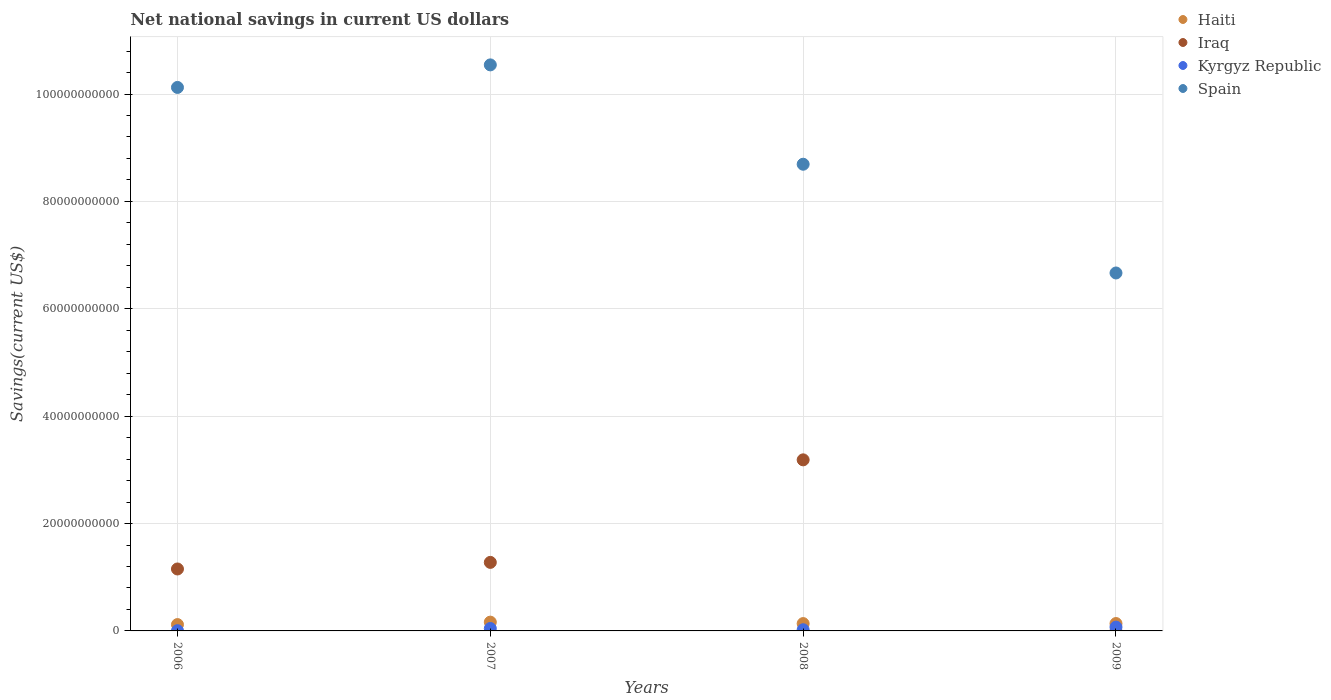How many different coloured dotlines are there?
Ensure brevity in your answer.  4. What is the net national savings in Kyrgyz Republic in 2009?
Ensure brevity in your answer.  7.09e+08. Across all years, what is the maximum net national savings in Haiti?
Provide a succinct answer. 1.64e+09. Across all years, what is the minimum net national savings in Iraq?
Offer a terse response. 0. What is the total net national savings in Spain in the graph?
Provide a succinct answer. 3.60e+11. What is the difference between the net national savings in Haiti in 2006 and that in 2008?
Offer a very short reply. -1.86e+08. What is the difference between the net national savings in Iraq in 2007 and the net national savings in Spain in 2008?
Keep it short and to the point. -7.42e+1. What is the average net national savings in Kyrgyz Republic per year?
Provide a succinct answer. 3.55e+08. In the year 2007, what is the difference between the net national savings in Spain and net national savings in Kyrgyz Republic?
Ensure brevity in your answer.  1.05e+11. What is the ratio of the net national savings in Spain in 2008 to that in 2009?
Your answer should be compact. 1.3. Is the difference between the net national savings in Spain in 2006 and 2007 greater than the difference between the net national savings in Kyrgyz Republic in 2006 and 2007?
Make the answer very short. No. What is the difference between the highest and the second highest net national savings in Iraq?
Give a very brief answer. 1.91e+1. What is the difference between the highest and the lowest net national savings in Kyrgyz Republic?
Offer a very short reply. 6.67e+08. In how many years, is the net national savings in Spain greater than the average net national savings in Spain taken over all years?
Ensure brevity in your answer.  2. Is it the case that in every year, the sum of the net national savings in Haiti and net national savings in Kyrgyz Republic  is greater than the sum of net national savings in Iraq and net national savings in Spain?
Make the answer very short. Yes. Is it the case that in every year, the sum of the net national savings in Iraq and net national savings in Haiti  is greater than the net national savings in Kyrgyz Republic?
Give a very brief answer. Yes. Is the net national savings in Spain strictly less than the net national savings in Iraq over the years?
Provide a short and direct response. No. How many dotlines are there?
Your answer should be compact. 4. Are the values on the major ticks of Y-axis written in scientific E-notation?
Offer a very short reply. No. Does the graph contain any zero values?
Offer a very short reply. Yes. How many legend labels are there?
Ensure brevity in your answer.  4. How are the legend labels stacked?
Ensure brevity in your answer.  Vertical. What is the title of the graph?
Offer a very short reply. Net national savings in current US dollars. Does "Greece" appear as one of the legend labels in the graph?
Keep it short and to the point. No. What is the label or title of the X-axis?
Offer a terse response. Years. What is the label or title of the Y-axis?
Your answer should be very brief. Savings(current US$). What is the Savings(current US$) in Haiti in 2006?
Provide a short and direct response. 1.18e+09. What is the Savings(current US$) of Iraq in 2006?
Ensure brevity in your answer.  1.15e+1. What is the Savings(current US$) in Kyrgyz Republic in 2006?
Give a very brief answer. 4.16e+07. What is the Savings(current US$) in Spain in 2006?
Offer a terse response. 1.01e+11. What is the Savings(current US$) in Haiti in 2007?
Give a very brief answer. 1.64e+09. What is the Savings(current US$) of Iraq in 2007?
Keep it short and to the point. 1.28e+1. What is the Savings(current US$) in Kyrgyz Republic in 2007?
Give a very brief answer. 4.53e+08. What is the Savings(current US$) in Spain in 2007?
Your answer should be compact. 1.05e+11. What is the Savings(current US$) of Haiti in 2008?
Provide a succinct answer. 1.37e+09. What is the Savings(current US$) in Iraq in 2008?
Your answer should be very brief. 3.19e+1. What is the Savings(current US$) of Kyrgyz Republic in 2008?
Offer a very short reply. 2.18e+08. What is the Savings(current US$) of Spain in 2008?
Provide a succinct answer. 8.69e+1. What is the Savings(current US$) of Haiti in 2009?
Ensure brevity in your answer.  1.38e+09. What is the Savings(current US$) of Kyrgyz Republic in 2009?
Make the answer very short. 7.09e+08. What is the Savings(current US$) of Spain in 2009?
Give a very brief answer. 6.67e+1. Across all years, what is the maximum Savings(current US$) of Haiti?
Make the answer very short. 1.64e+09. Across all years, what is the maximum Savings(current US$) of Iraq?
Your answer should be compact. 3.19e+1. Across all years, what is the maximum Savings(current US$) in Kyrgyz Republic?
Make the answer very short. 7.09e+08. Across all years, what is the maximum Savings(current US$) of Spain?
Keep it short and to the point. 1.05e+11. Across all years, what is the minimum Savings(current US$) in Haiti?
Provide a short and direct response. 1.18e+09. Across all years, what is the minimum Savings(current US$) of Iraq?
Provide a short and direct response. 0. Across all years, what is the minimum Savings(current US$) in Kyrgyz Republic?
Provide a short and direct response. 4.16e+07. Across all years, what is the minimum Savings(current US$) in Spain?
Provide a succinct answer. 6.67e+1. What is the total Savings(current US$) in Haiti in the graph?
Give a very brief answer. 5.56e+09. What is the total Savings(current US$) in Iraq in the graph?
Offer a very short reply. 5.62e+1. What is the total Savings(current US$) in Kyrgyz Republic in the graph?
Ensure brevity in your answer.  1.42e+09. What is the total Savings(current US$) in Spain in the graph?
Provide a succinct answer. 3.60e+11. What is the difference between the Savings(current US$) of Haiti in 2006 and that in 2007?
Provide a short and direct response. -4.55e+08. What is the difference between the Savings(current US$) in Iraq in 2006 and that in 2007?
Provide a succinct answer. -1.23e+09. What is the difference between the Savings(current US$) in Kyrgyz Republic in 2006 and that in 2007?
Give a very brief answer. -4.11e+08. What is the difference between the Savings(current US$) of Spain in 2006 and that in 2007?
Provide a short and direct response. -4.20e+09. What is the difference between the Savings(current US$) of Haiti in 2006 and that in 2008?
Your answer should be compact. -1.86e+08. What is the difference between the Savings(current US$) of Iraq in 2006 and that in 2008?
Give a very brief answer. -2.03e+1. What is the difference between the Savings(current US$) of Kyrgyz Republic in 2006 and that in 2008?
Offer a very short reply. -1.77e+08. What is the difference between the Savings(current US$) in Spain in 2006 and that in 2008?
Your answer should be compact. 1.43e+1. What is the difference between the Savings(current US$) of Haiti in 2006 and that in 2009?
Offer a terse response. -1.95e+08. What is the difference between the Savings(current US$) in Kyrgyz Republic in 2006 and that in 2009?
Provide a short and direct response. -6.67e+08. What is the difference between the Savings(current US$) in Spain in 2006 and that in 2009?
Your response must be concise. 3.46e+1. What is the difference between the Savings(current US$) of Haiti in 2007 and that in 2008?
Offer a terse response. 2.69e+08. What is the difference between the Savings(current US$) of Iraq in 2007 and that in 2008?
Give a very brief answer. -1.91e+1. What is the difference between the Savings(current US$) of Kyrgyz Republic in 2007 and that in 2008?
Your response must be concise. 2.34e+08. What is the difference between the Savings(current US$) in Spain in 2007 and that in 2008?
Your answer should be compact. 1.85e+1. What is the difference between the Savings(current US$) of Haiti in 2007 and that in 2009?
Provide a succinct answer. 2.60e+08. What is the difference between the Savings(current US$) of Kyrgyz Republic in 2007 and that in 2009?
Your response must be concise. -2.56e+08. What is the difference between the Savings(current US$) of Spain in 2007 and that in 2009?
Keep it short and to the point. 3.88e+1. What is the difference between the Savings(current US$) of Haiti in 2008 and that in 2009?
Your answer should be compact. -9.73e+06. What is the difference between the Savings(current US$) in Kyrgyz Republic in 2008 and that in 2009?
Your answer should be compact. -4.90e+08. What is the difference between the Savings(current US$) in Spain in 2008 and that in 2009?
Provide a succinct answer. 2.03e+1. What is the difference between the Savings(current US$) in Haiti in 2006 and the Savings(current US$) in Iraq in 2007?
Ensure brevity in your answer.  -1.16e+1. What is the difference between the Savings(current US$) in Haiti in 2006 and the Savings(current US$) in Kyrgyz Republic in 2007?
Provide a succinct answer. 7.28e+08. What is the difference between the Savings(current US$) in Haiti in 2006 and the Savings(current US$) in Spain in 2007?
Give a very brief answer. -1.04e+11. What is the difference between the Savings(current US$) of Iraq in 2006 and the Savings(current US$) of Kyrgyz Republic in 2007?
Make the answer very short. 1.11e+1. What is the difference between the Savings(current US$) in Iraq in 2006 and the Savings(current US$) in Spain in 2007?
Give a very brief answer. -9.39e+1. What is the difference between the Savings(current US$) of Kyrgyz Republic in 2006 and the Savings(current US$) of Spain in 2007?
Give a very brief answer. -1.05e+11. What is the difference between the Savings(current US$) of Haiti in 2006 and the Savings(current US$) of Iraq in 2008?
Provide a short and direct response. -3.07e+1. What is the difference between the Savings(current US$) of Haiti in 2006 and the Savings(current US$) of Kyrgyz Republic in 2008?
Provide a succinct answer. 9.62e+08. What is the difference between the Savings(current US$) in Haiti in 2006 and the Savings(current US$) in Spain in 2008?
Keep it short and to the point. -8.57e+1. What is the difference between the Savings(current US$) in Iraq in 2006 and the Savings(current US$) in Kyrgyz Republic in 2008?
Your response must be concise. 1.13e+1. What is the difference between the Savings(current US$) in Iraq in 2006 and the Savings(current US$) in Spain in 2008?
Provide a short and direct response. -7.54e+1. What is the difference between the Savings(current US$) of Kyrgyz Republic in 2006 and the Savings(current US$) of Spain in 2008?
Make the answer very short. -8.69e+1. What is the difference between the Savings(current US$) of Haiti in 2006 and the Savings(current US$) of Kyrgyz Republic in 2009?
Provide a short and direct response. 4.72e+08. What is the difference between the Savings(current US$) in Haiti in 2006 and the Savings(current US$) in Spain in 2009?
Offer a terse response. -6.55e+1. What is the difference between the Savings(current US$) in Iraq in 2006 and the Savings(current US$) in Kyrgyz Republic in 2009?
Provide a short and direct response. 1.08e+1. What is the difference between the Savings(current US$) of Iraq in 2006 and the Savings(current US$) of Spain in 2009?
Your response must be concise. -5.51e+1. What is the difference between the Savings(current US$) of Kyrgyz Republic in 2006 and the Savings(current US$) of Spain in 2009?
Keep it short and to the point. -6.66e+1. What is the difference between the Savings(current US$) in Haiti in 2007 and the Savings(current US$) in Iraq in 2008?
Your response must be concise. -3.02e+1. What is the difference between the Savings(current US$) of Haiti in 2007 and the Savings(current US$) of Kyrgyz Republic in 2008?
Provide a short and direct response. 1.42e+09. What is the difference between the Savings(current US$) of Haiti in 2007 and the Savings(current US$) of Spain in 2008?
Offer a terse response. -8.53e+1. What is the difference between the Savings(current US$) in Iraq in 2007 and the Savings(current US$) in Kyrgyz Republic in 2008?
Your answer should be very brief. 1.25e+1. What is the difference between the Savings(current US$) in Iraq in 2007 and the Savings(current US$) in Spain in 2008?
Offer a terse response. -7.42e+1. What is the difference between the Savings(current US$) in Kyrgyz Republic in 2007 and the Savings(current US$) in Spain in 2008?
Offer a terse response. -8.65e+1. What is the difference between the Savings(current US$) in Haiti in 2007 and the Savings(current US$) in Kyrgyz Republic in 2009?
Provide a succinct answer. 9.27e+08. What is the difference between the Savings(current US$) in Haiti in 2007 and the Savings(current US$) in Spain in 2009?
Make the answer very short. -6.50e+1. What is the difference between the Savings(current US$) of Iraq in 2007 and the Savings(current US$) of Kyrgyz Republic in 2009?
Give a very brief answer. 1.21e+1. What is the difference between the Savings(current US$) in Iraq in 2007 and the Savings(current US$) in Spain in 2009?
Make the answer very short. -5.39e+1. What is the difference between the Savings(current US$) in Kyrgyz Republic in 2007 and the Savings(current US$) in Spain in 2009?
Your answer should be very brief. -6.62e+1. What is the difference between the Savings(current US$) in Haiti in 2008 and the Savings(current US$) in Kyrgyz Republic in 2009?
Keep it short and to the point. 6.58e+08. What is the difference between the Savings(current US$) of Haiti in 2008 and the Savings(current US$) of Spain in 2009?
Keep it short and to the point. -6.53e+1. What is the difference between the Savings(current US$) in Iraq in 2008 and the Savings(current US$) in Kyrgyz Republic in 2009?
Give a very brief answer. 3.12e+1. What is the difference between the Savings(current US$) of Iraq in 2008 and the Savings(current US$) of Spain in 2009?
Provide a short and direct response. -3.48e+1. What is the difference between the Savings(current US$) of Kyrgyz Republic in 2008 and the Savings(current US$) of Spain in 2009?
Your answer should be compact. -6.64e+1. What is the average Savings(current US$) of Haiti per year?
Give a very brief answer. 1.39e+09. What is the average Savings(current US$) of Iraq per year?
Provide a succinct answer. 1.40e+1. What is the average Savings(current US$) of Kyrgyz Republic per year?
Ensure brevity in your answer.  3.55e+08. What is the average Savings(current US$) in Spain per year?
Your response must be concise. 9.01e+1. In the year 2006, what is the difference between the Savings(current US$) in Haiti and Savings(current US$) in Iraq?
Give a very brief answer. -1.04e+1. In the year 2006, what is the difference between the Savings(current US$) of Haiti and Savings(current US$) of Kyrgyz Republic?
Give a very brief answer. 1.14e+09. In the year 2006, what is the difference between the Savings(current US$) in Haiti and Savings(current US$) in Spain?
Make the answer very short. -1.00e+11. In the year 2006, what is the difference between the Savings(current US$) of Iraq and Savings(current US$) of Kyrgyz Republic?
Give a very brief answer. 1.15e+1. In the year 2006, what is the difference between the Savings(current US$) of Iraq and Savings(current US$) of Spain?
Make the answer very short. -8.97e+1. In the year 2006, what is the difference between the Savings(current US$) in Kyrgyz Republic and Savings(current US$) in Spain?
Your response must be concise. -1.01e+11. In the year 2007, what is the difference between the Savings(current US$) in Haiti and Savings(current US$) in Iraq?
Your response must be concise. -1.11e+1. In the year 2007, what is the difference between the Savings(current US$) of Haiti and Savings(current US$) of Kyrgyz Republic?
Provide a succinct answer. 1.18e+09. In the year 2007, what is the difference between the Savings(current US$) of Haiti and Savings(current US$) of Spain?
Offer a very short reply. -1.04e+11. In the year 2007, what is the difference between the Savings(current US$) of Iraq and Savings(current US$) of Kyrgyz Republic?
Make the answer very short. 1.23e+1. In the year 2007, what is the difference between the Savings(current US$) of Iraq and Savings(current US$) of Spain?
Your response must be concise. -9.27e+1. In the year 2007, what is the difference between the Savings(current US$) in Kyrgyz Republic and Savings(current US$) in Spain?
Make the answer very short. -1.05e+11. In the year 2008, what is the difference between the Savings(current US$) of Haiti and Savings(current US$) of Iraq?
Give a very brief answer. -3.05e+1. In the year 2008, what is the difference between the Savings(current US$) of Haiti and Savings(current US$) of Kyrgyz Republic?
Your answer should be compact. 1.15e+09. In the year 2008, what is the difference between the Savings(current US$) in Haiti and Savings(current US$) in Spain?
Offer a very short reply. -8.56e+1. In the year 2008, what is the difference between the Savings(current US$) in Iraq and Savings(current US$) in Kyrgyz Republic?
Give a very brief answer. 3.16e+1. In the year 2008, what is the difference between the Savings(current US$) of Iraq and Savings(current US$) of Spain?
Your response must be concise. -5.51e+1. In the year 2008, what is the difference between the Savings(current US$) of Kyrgyz Republic and Savings(current US$) of Spain?
Your response must be concise. -8.67e+1. In the year 2009, what is the difference between the Savings(current US$) in Haiti and Savings(current US$) in Kyrgyz Republic?
Your response must be concise. 6.67e+08. In the year 2009, what is the difference between the Savings(current US$) in Haiti and Savings(current US$) in Spain?
Ensure brevity in your answer.  -6.53e+1. In the year 2009, what is the difference between the Savings(current US$) of Kyrgyz Republic and Savings(current US$) of Spain?
Ensure brevity in your answer.  -6.60e+1. What is the ratio of the Savings(current US$) of Haiti in 2006 to that in 2007?
Offer a very short reply. 0.72. What is the ratio of the Savings(current US$) in Iraq in 2006 to that in 2007?
Offer a terse response. 0.9. What is the ratio of the Savings(current US$) of Kyrgyz Republic in 2006 to that in 2007?
Ensure brevity in your answer.  0.09. What is the ratio of the Savings(current US$) in Spain in 2006 to that in 2007?
Your answer should be very brief. 0.96. What is the ratio of the Savings(current US$) of Haiti in 2006 to that in 2008?
Your answer should be very brief. 0.86. What is the ratio of the Savings(current US$) in Iraq in 2006 to that in 2008?
Offer a terse response. 0.36. What is the ratio of the Savings(current US$) in Kyrgyz Republic in 2006 to that in 2008?
Make the answer very short. 0.19. What is the ratio of the Savings(current US$) of Spain in 2006 to that in 2008?
Your answer should be compact. 1.16. What is the ratio of the Savings(current US$) of Haiti in 2006 to that in 2009?
Provide a succinct answer. 0.86. What is the ratio of the Savings(current US$) in Kyrgyz Republic in 2006 to that in 2009?
Your answer should be very brief. 0.06. What is the ratio of the Savings(current US$) of Spain in 2006 to that in 2009?
Give a very brief answer. 1.52. What is the ratio of the Savings(current US$) of Haiti in 2007 to that in 2008?
Give a very brief answer. 1.2. What is the ratio of the Savings(current US$) in Iraq in 2007 to that in 2008?
Offer a terse response. 0.4. What is the ratio of the Savings(current US$) in Kyrgyz Republic in 2007 to that in 2008?
Keep it short and to the point. 2.07. What is the ratio of the Savings(current US$) of Spain in 2007 to that in 2008?
Your answer should be very brief. 1.21. What is the ratio of the Savings(current US$) of Haiti in 2007 to that in 2009?
Your response must be concise. 1.19. What is the ratio of the Savings(current US$) in Kyrgyz Republic in 2007 to that in 2009?
Make the answer very short. 0.64. What is the ratio of the Savings(current US$) in Spain in 2007 to that in 2009?
Make the answer very short. 1.58. What is the ratio of the Savings(current US$) of Haiti in 2008 to that in 2009?
Your answer should be compact. 0.99. What is the ratio of the Savings(current US$) of Kyrgyz Republic in 2008 to that in 2009?
Give a very brief answer. 0.31. What is the ratio of the Savings(current US$) in Spain in 2008 to that in 2009?
Your answer should be compact. 1.3. What is the difference between the highest and the second highest Savings(current US$) in Haiti?
Your response must be concise. 2.60e+08. What is the difference between the highest and the second highest Savings(current US$) in Iraq?
Your answer should be compact. 1.91e+1. What is the difference between the highest and the second highest Savings(current US$) in Kyrgyz Republic?
Give a very brief answer. 2.56e+08. What is the difference between the highest and the second highest Savings(current US$) of Spain?
Keep it short and to the point. 4.20e+09. What is the difference between the highest and the lowest Savings(current US$) in Haiti?
Offer a terse response. 4.55e+08. What is the difference between the highest and the lowest Savings(current US$) in Iraq?
Keep it short and to the point. 3.19e+1. What is the difference between the highest and the lowest Savings(current US$) in Kyrgyz Republic?
Provide a succinct answer. 6.67e+08. What is the difference between the highest and the lowest Savings(current US$) of Spain?
Provide a short and direct response. 3.88e+1. 